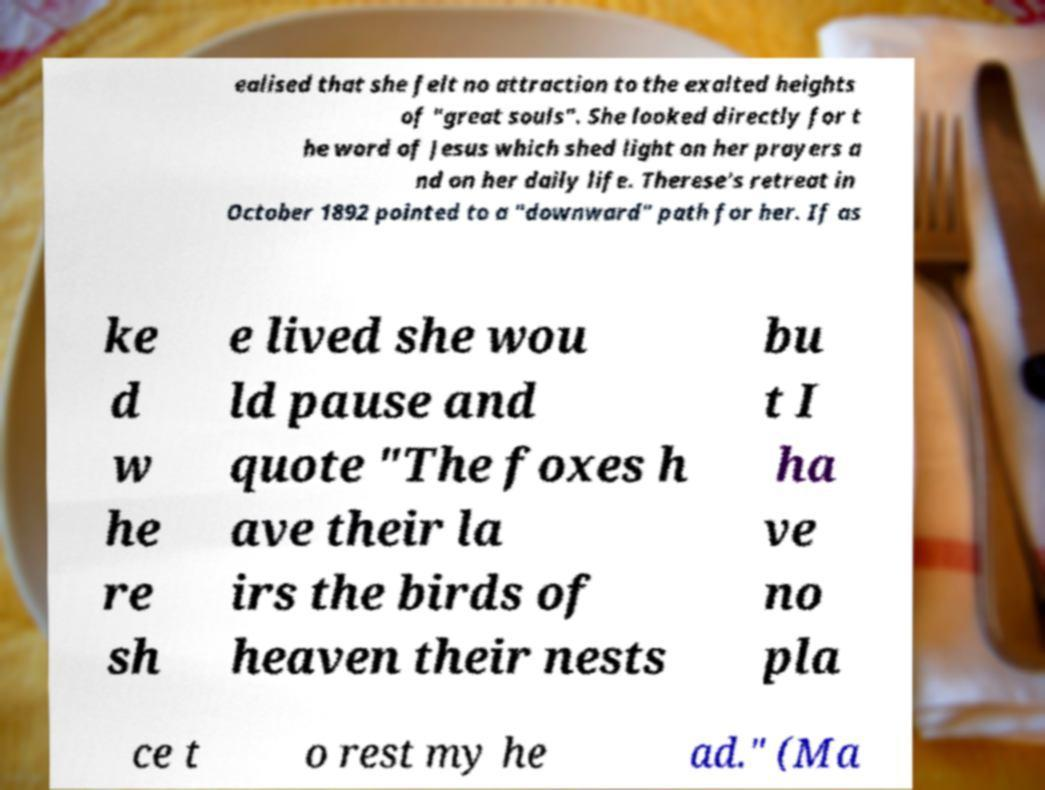Can you read and provide the text displayed in the image?This photo seems to have some interesting text. Can you extract and type it out for me? ealised that she felt no attraction to the exalted heights of "great souls". She looked directly for t he word of Jesus which shed light on her prayers a nd on her daily life. Therese's retreat in October 1892 pointed to a "downward" path for her. If as ke d w he re sh e lived she wou ld pause and quote "The foxes h ave their la irs the birds of heaven their nests bu t I ha ve no pla ce t o rest my he ad." (Ma 